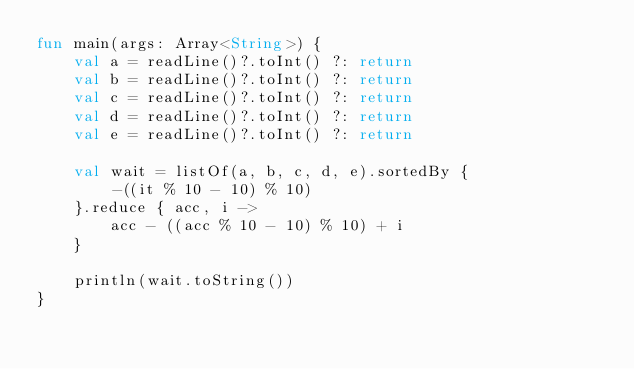<code> <loc_0><loc_0><loc_500><loc_500><_Kotlin_>fun main(args: Array<String>) {
    val a = readLine()?.toInt() ?: return
    val b = readLine()?.toInt() ?: return
    val c = readLine()?.toInt() ?: return
    val d = readLine()?.toInt() ?: return
    val e = readLine()?.toInt() ?: return

    val wait = listOf(a, b, c, d, e).sortedBy {
        -((it % 10 - 10) % 10)
    }.reduce { acc, i ->
        acc - ((acc % 10 - 10) % 10) + i
    }

    println(wait.toString())
}</code> 